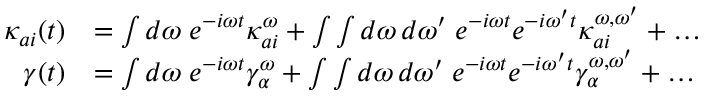Convert formula to latex. <formula><loc_0><loc_0><loc_500><loc_500>\begin{array} { r l } { \kappa _ { a i } ( t ) } & { = \int d \omega \, e ^ { - i \omega t } \kappa _ { a i } ^ { \omega } + \int \int d \omega \, d \omega ^ { \prime } \, e ^ { - i \omega t } e ^ { - i \omega ^ { \prime } t } \kappa _ { a i } ^ { \omega , \omega ^ { \prime } } + \dots } \\ { \gamma ( t ) } & { = \int d \omega \, e ^ { - i \omega t } \gamma _ { \alpha } ^ { \omega } + \int \int d \omega \, d \omega ^ { \prime } \, e ^ { - i \omega t } e ^ { - i \omega ^ { \prime } t } \gamma _ { \alpha } ^ { \omega , \omega ^ { \prime } } + \dots } \end{array}</formula> 